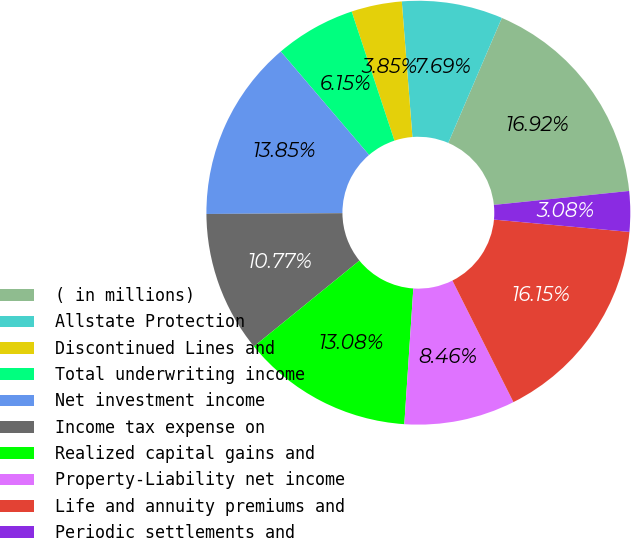<chart> <loc_0><loc_0><loc_500><loc_500><pie_chart><fcel>( in millions)<fcel>Allstate Protection<fcel>Discontinued Lines and<fcel>Total underwriting income<fcel>Net investment income<fcel>Income tax expense on<fcel>Realized capital gains and<fcel>Property-Liability net income<fcel>Life and annuity premiums and<fcel>Periodic settlements and<nl><fcel>16.92%<fcel>7.69%<fcel>3.85%<fcel>6.15%<fcel>13.85%<fcel>10.77%<fcel>13.08%<fcel>8.46%<fcel>16.15%<fcel>3.08%<nl></chart> 